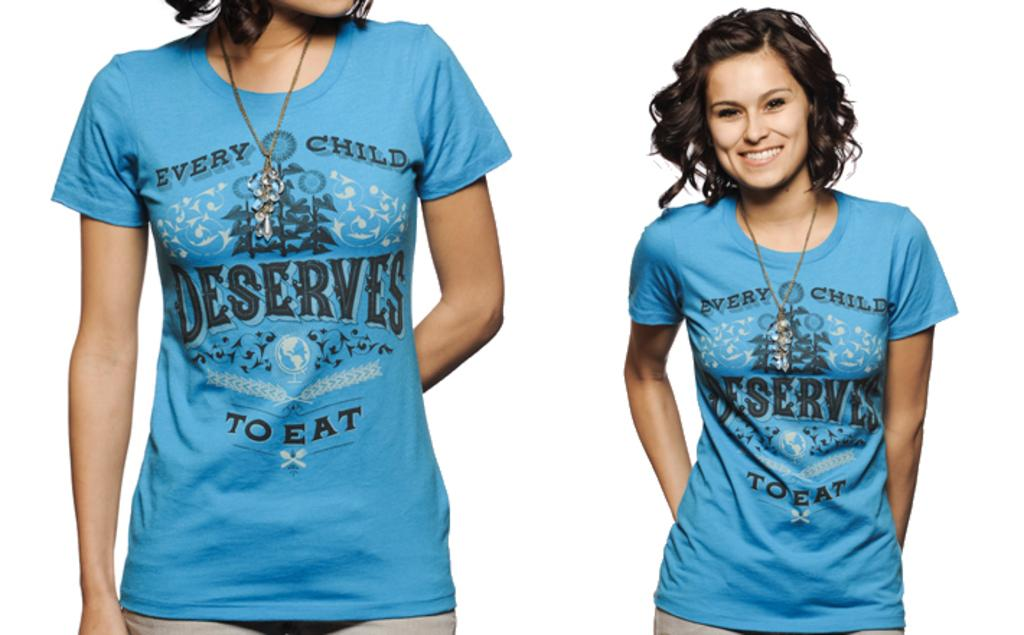<image>
Present a compact description of the photo's key features. the word deserves is on a blue shirt 